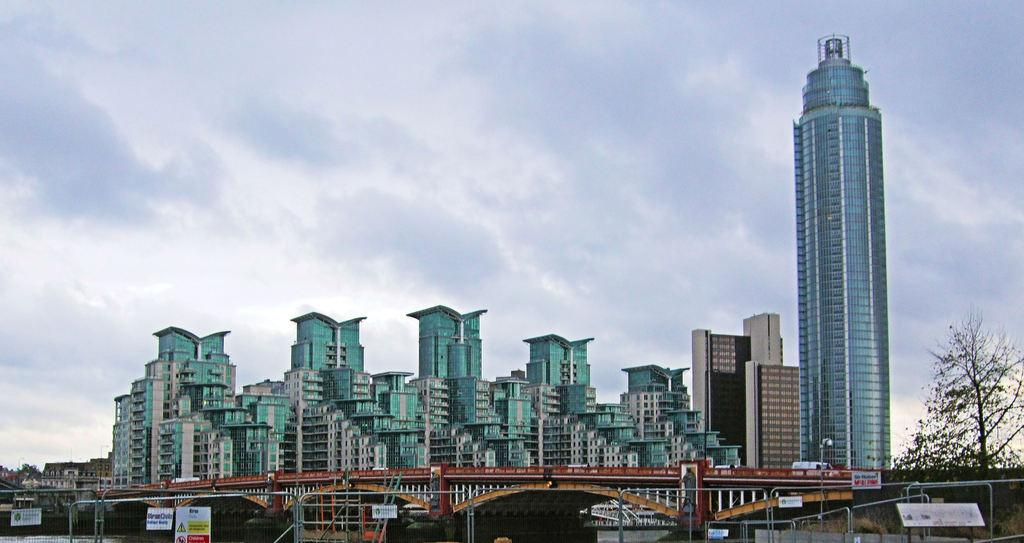What type of structures can be seen in the image? There are buildings with windows in the image. What other elements can be found in the image? There are trees, poles, metallic objects, a bridge, and a poster with text and images in the image. What is visible in the sky in the image? The sky is visible in the image, and clouds are present. Can you see any mice running on the bridge in the image? There are no mice present in the image; it features buildings, trees, poles, metallic objects, a bridge, and a poster with text and images. What type of blade is being used to cut the poster in the image? There is no blade present in the image, nor is there any indication that the poster is being cut. 